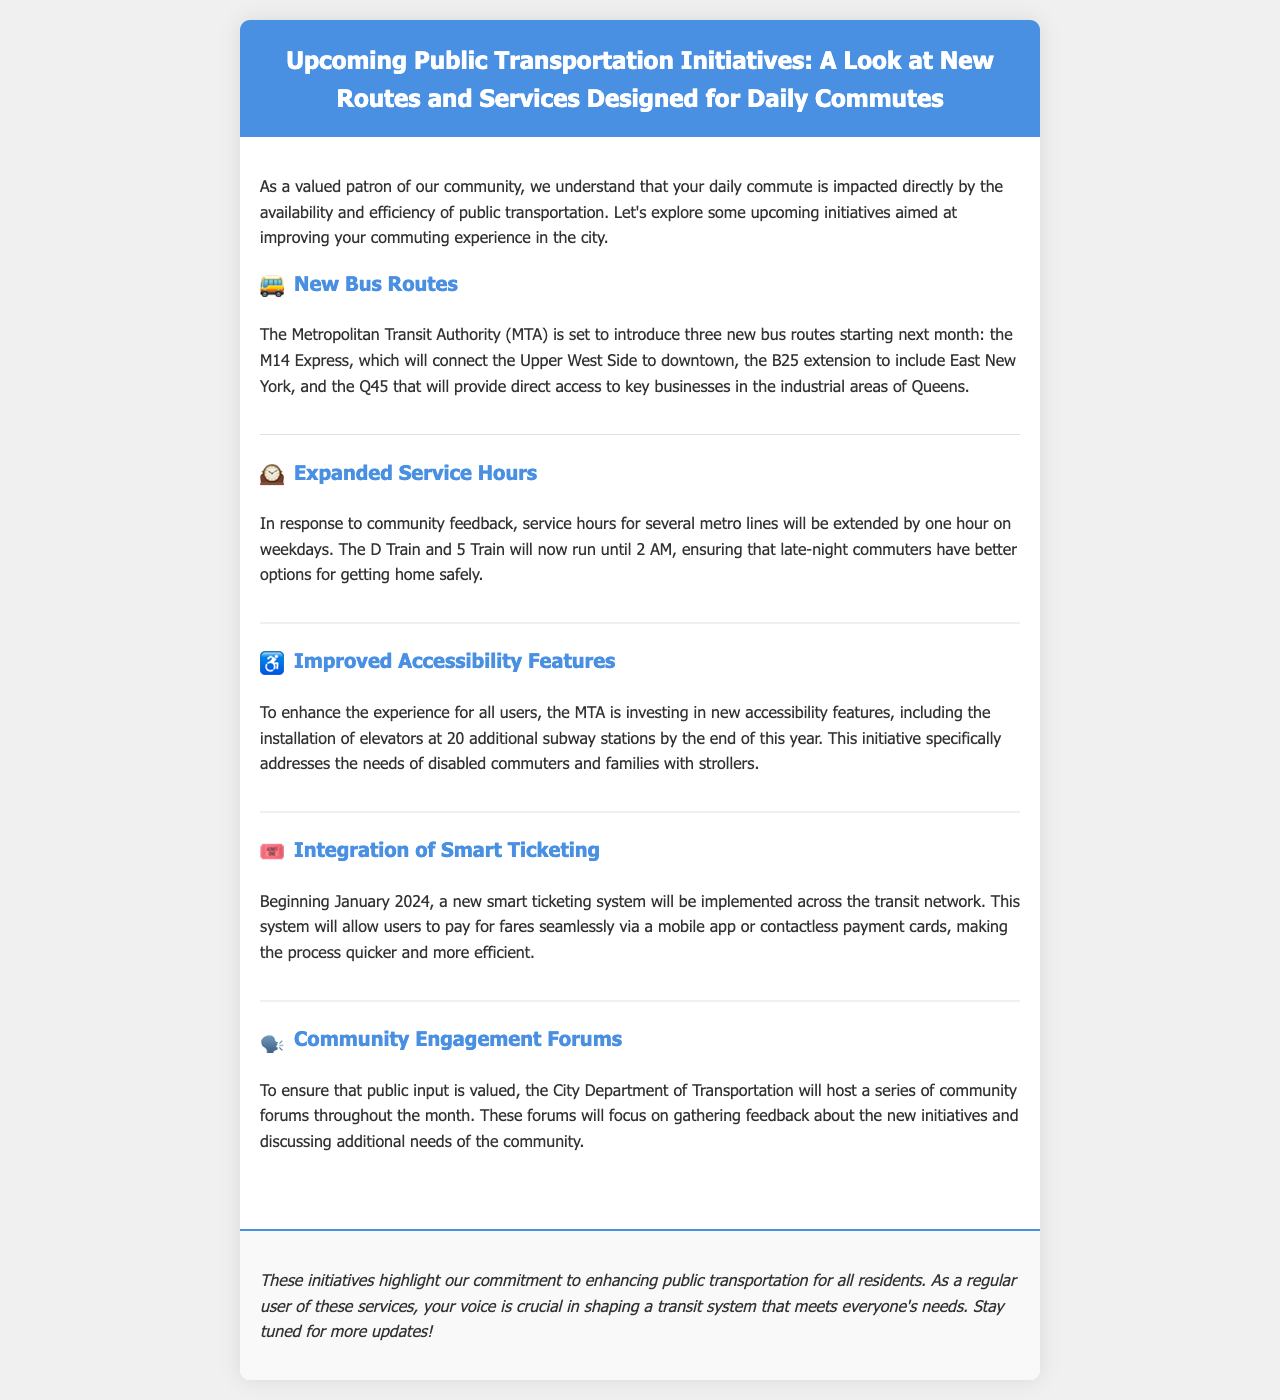What are the new bus routes being introduced? The document lists three new bus routes being introduced by the MTA: the M14 Express, the B25 extension, and the Q45.
Answer: M14 Express, B25 extension, Q45 What is the extended service hour for the D Train? The document states that the D Train will now run until 2 AM on weekdays, extending its service by one hour.
Answer: 2 AM How many subway stations will have new accessibility features installed? The document mentions that 20 additional subway stations will have elevators installed by the end of this year to enhance accessibility.
Answer: 20 When will the smart ticketing system be implemented? According to the document, the smart ticketing system will be implemented across the transit network beginning in January 2024.
Answer: January 2024 What is the purpose of the community engagement forums? The document states that the forums aim to gather feedback about the new initiatives and discuss additional community needs.
Answer: Gather feedback What initiative is specifically focused on families with strollers? The document highlights the installation of elevators at subway stations as an initiative to address the needs of disabled commuters and families with strollers.
Answer: Installation of elevators How does the newsletter emphasize community involvement? The newsletter emphasizes community involvement through the hosting of community forums to gather public input on transit initiatives.
Answer: Hosting forums Which department is hosting the community forums? The document specifies that the City Department of Transportation will host the community forums throughout the month.
Answer: City Department of Transportation 